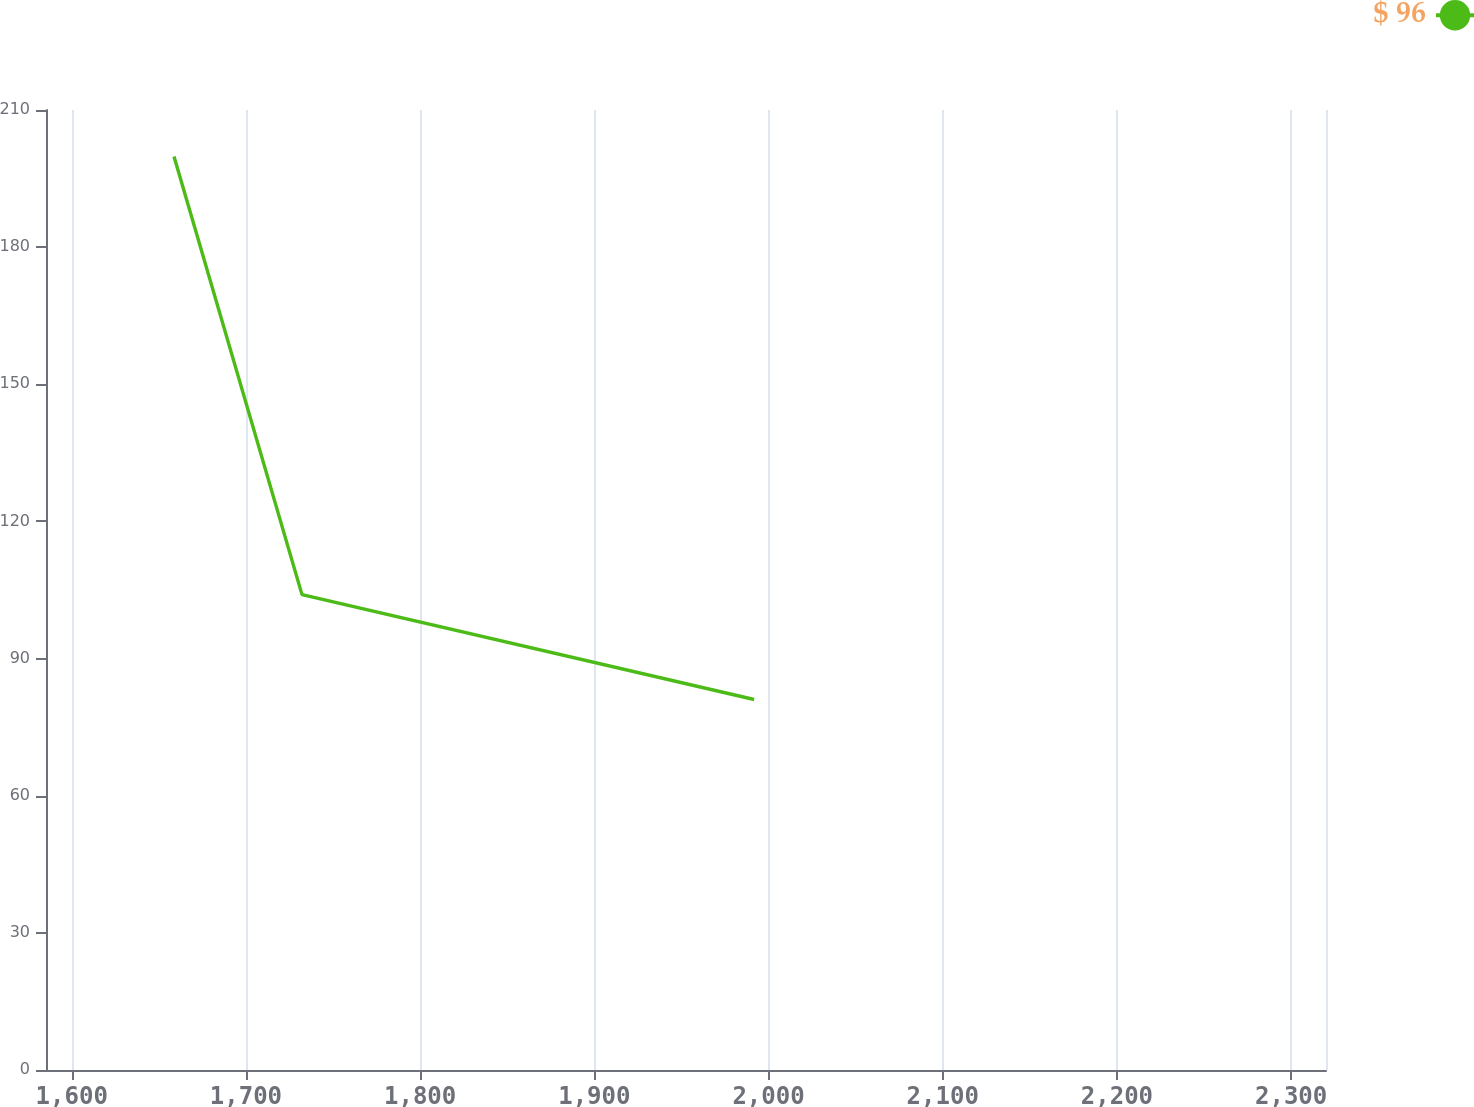<chart> <loc_0><loc_0><loc_500><loc_500><line_chart><ecel><fcel>$ 96<nl><fcel>1658.7<fcel>199.81<nl><fcel>1732.18<fcel>103.99<nl><fcel>1991.73<fcel>81.05<nl><fcel>2393.51<fcel>132.46<nl></chart> 